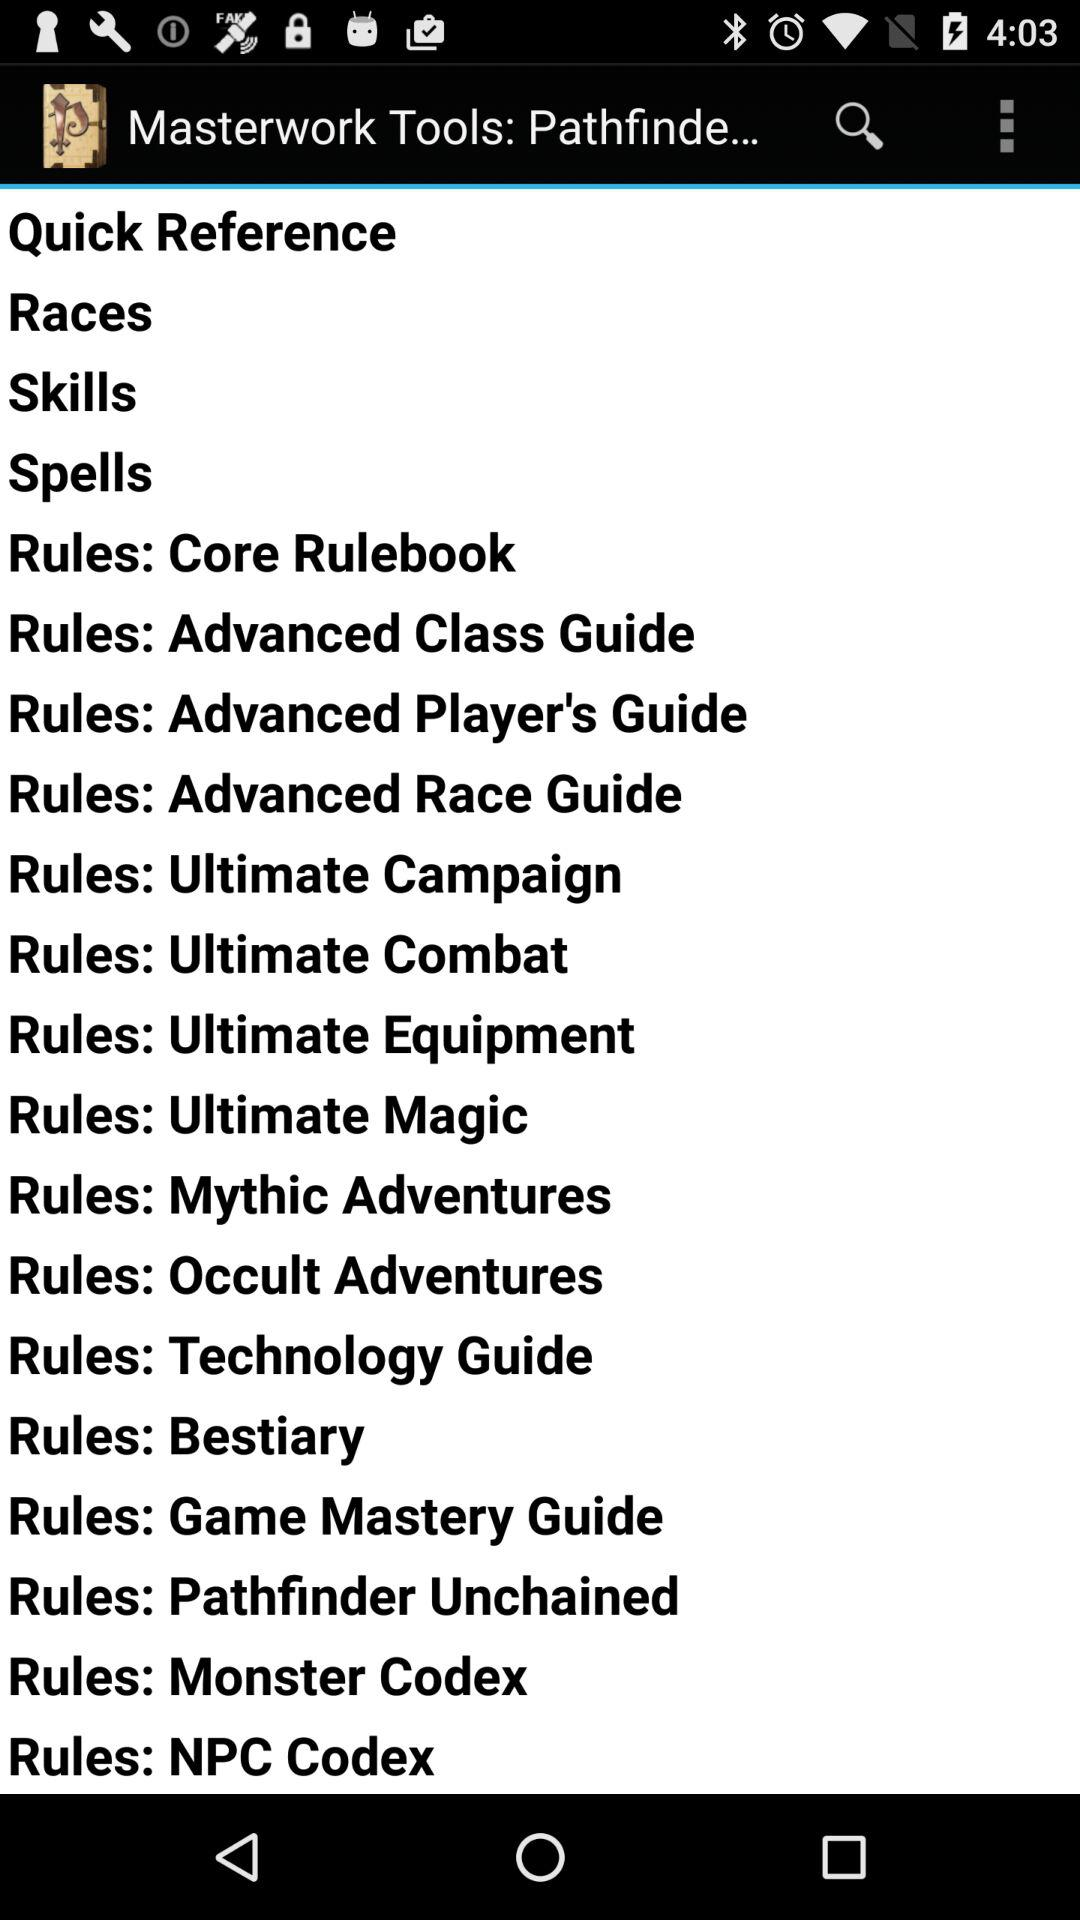What is the application name? The application name is "Masterwork Tools: Pathfinde...". 